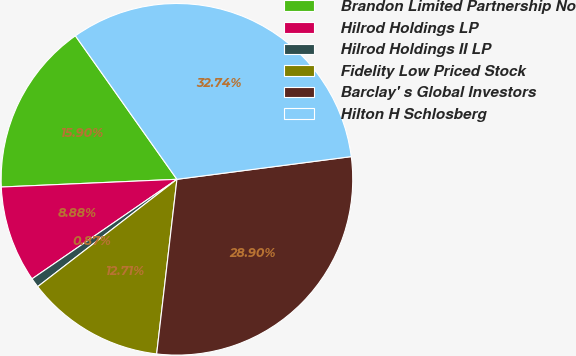Convert chart to OTSL. <chart><loc_0><loc_0><loc_500><loc_500><pie_chart><fcel>Brandon Limited Partnership No<fcel>Hilrod Holdings LP<fcel>Hilrod Holdings II LP<fcel>Fidelity Low Priced Stock<fcel>Barclay' s Global Investors<fcel>Hilton H Schlosberg<nl><fcel>15.9%<fcel>8.88%<fcel>0.87%<fcel>12.71%<fcel>28.9%<fcel>32.74%<nl></chart> 